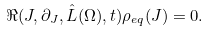Convert formula to latex. <formula><loc_0><loc_0><loc_500><loc_500>\Re ( J , \partial _ { J } , \hat { L } ( \Omega ) , t ) \rho _ { e q } ( J ) = 0 .</formula> 